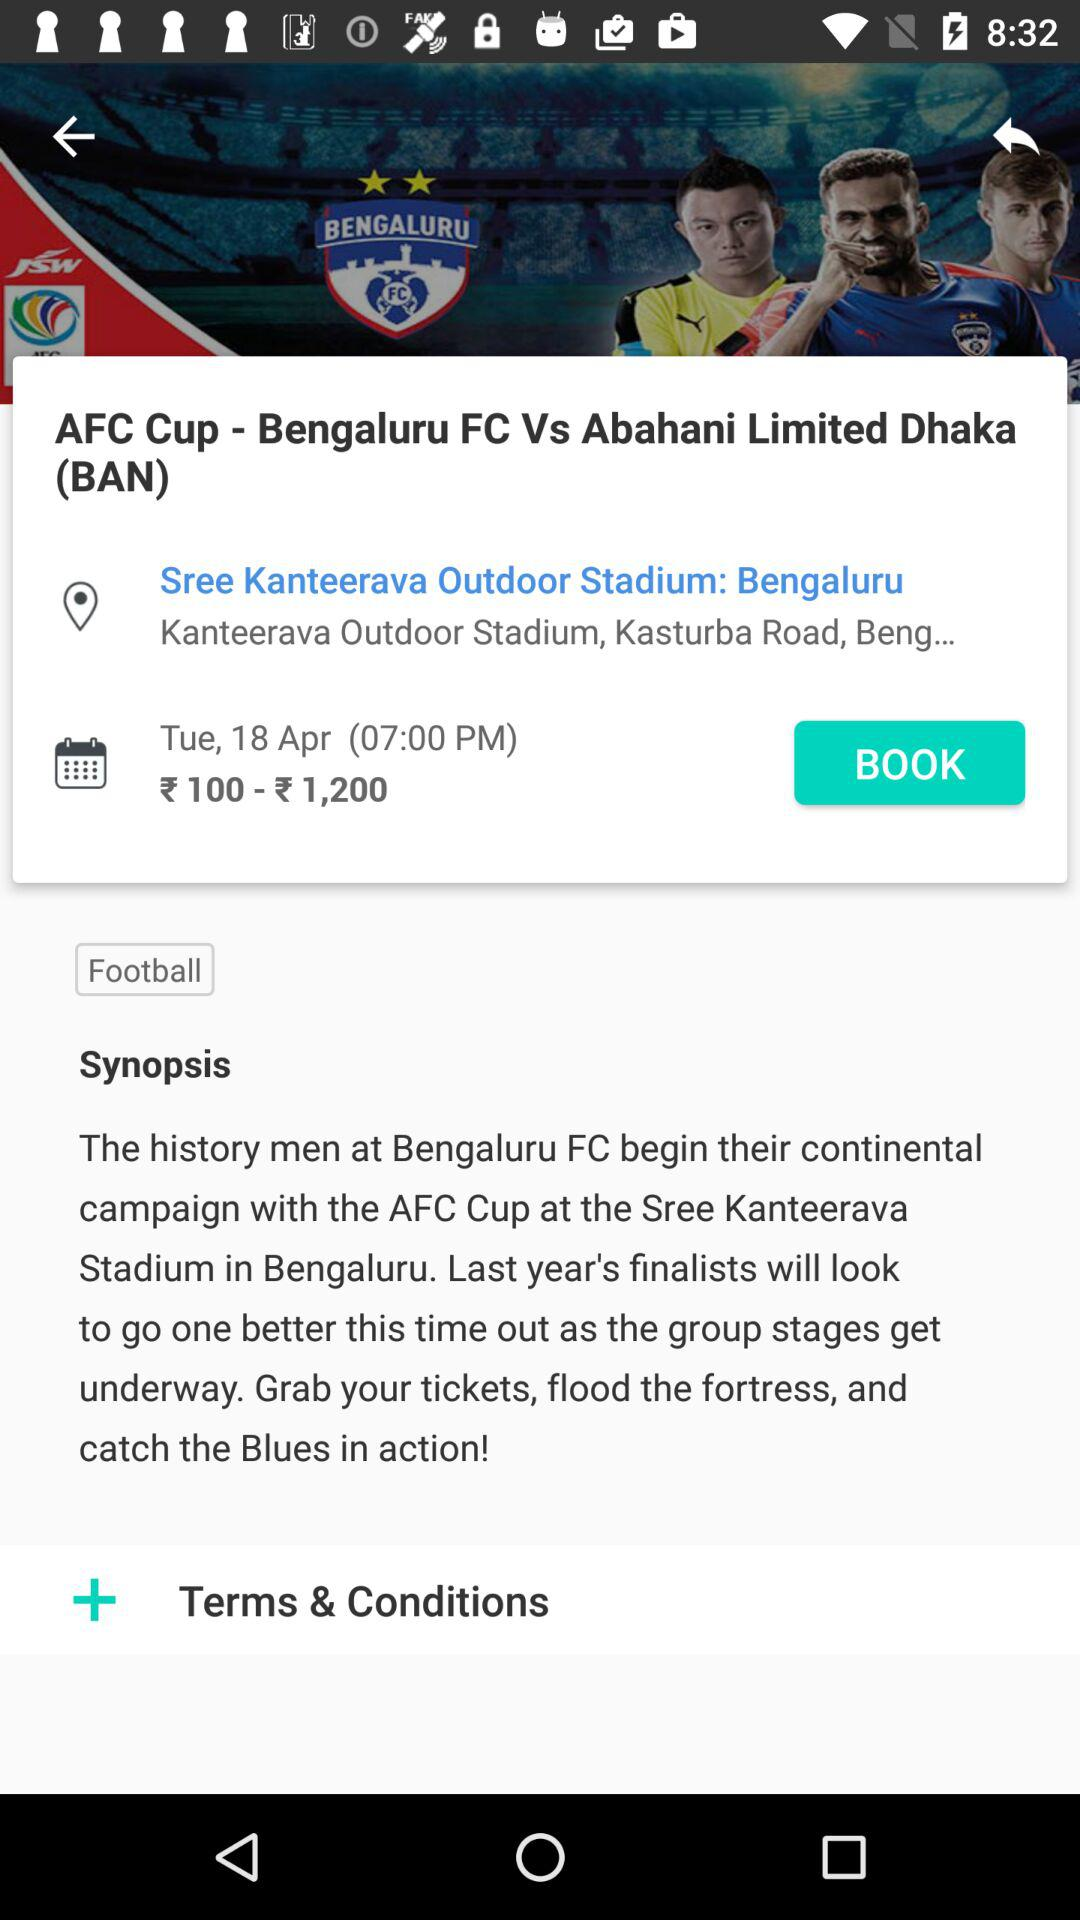What date is scheduled for the football match? The scheduled date is Tuesday, April 18. 